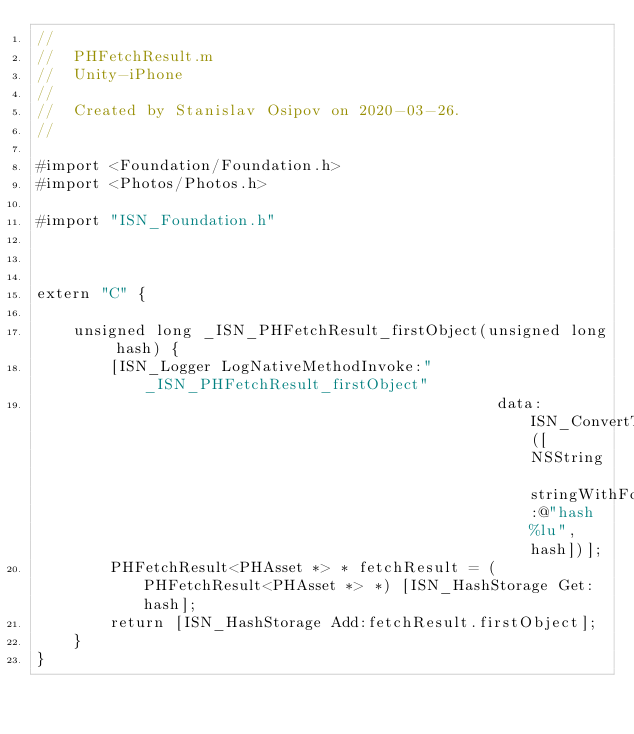Convert code to text. <code><loc_0><loc_0><loc_500><loc_500><_ObjectiveC_>//
//  PHFetchResult.m
//  Unity-iPhone
//
//  Created by Stanislav Osipov on 2020-03-26.
//

#import <Foundation/Foundation.h>
#import <Photos/Photos.h>

#import "ISN_Foundation.h"



extern "C" {

    unsigned long _ISN_PHFetchResult_firstObject(unsigned long hash) {
        [ISN_Logger LogNativeMethodInvoke:"_ISN_PHFetchResult_firstObject"
                                                  data: ISN_ConvertToChar([NSString stringWithFormat:@"hash %lu", hash])];
        PHFetchResult<PHAsset *> * fetchResult = (PHFetchResult<PHAsset *> *) [ISN_HashStorage Get: hash];
        return [ISN_HashStorage Add:fetchResult.firstObject];
    }
}
</code> 